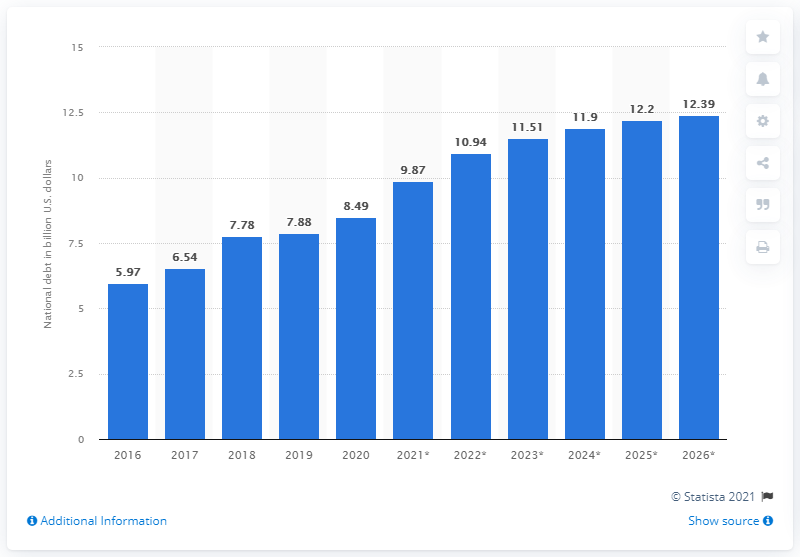Outline some significant characteristics in this image. In 2020, the national debt of the Bahamas was 8.49 million dollars. In 2020, the national debt of the Bahamas came to an end. 